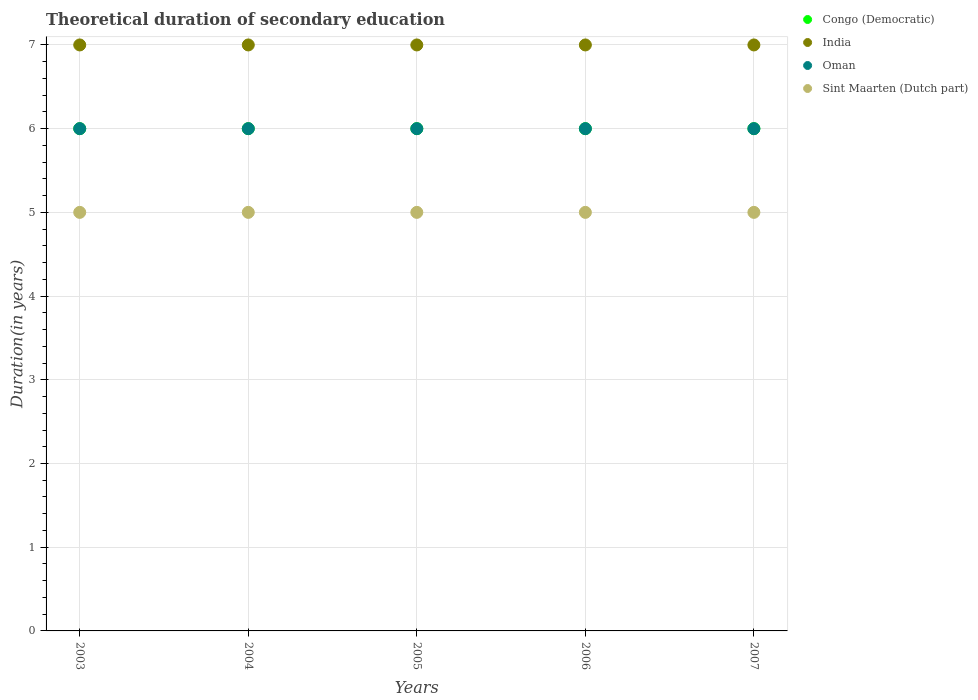How many different coloured dotlines are there?
Offer a terse response. 4. Across all years, what is the maximum total theoretical duration of secondary education in India?
Your response must be concise. 7. In which year was the total theoretical duration of secondary education in Congo (Democratic) maximum?
Offer a very short reply. 2003. What is the total total theoretical duration of secondary education in Oman in the graph?
Ensure brevity in your answer.  30. What is the average total theoretical duration of secondary education in Sint Maarten (Dutch part) per year?
Ensure brevity in your answer.  5. What is the ratio of the total theoretical duration of secondary education in Oman in 2003 to that in 2005?
Ensure brevity in your answer.  1. Is the total theoretical duration of secondary education in India in 2003 less than that in 2006?
Offer a terse response. No. Is the difference between the total theoretical duration of secondary education in Oman in 2005 and 2007 greater than the difference between the total theoretical duration of secondary education in Congo (Democratic) in 2005 and 2007?
Provide a succinct answer. No. What is the difference between the highest and the second highest total theoretical duration of secondary education in India?
Your answer should be very brief. 0. What is the difference between the highest and the lowest total theoretical duration of secondary education in Oman?
Make the answer very short. 0. Is it the case that in every year, the sum of the total theoretical duration of secondary education in Sint Maarten (Dutch part) and total theoretical duration of secondary education in Oman  is greater than the sum of total theoretical duration of secondary education in Congo (Democratic) and total theoretical duration of secondary education in India?
Your answer should be compact. No. Is the total theoretical duration of secondary education in Congo (Democratic) strictly greater than the total theoretical duration of secondary education in India over the years?
Ensure brevity in your answer.  No. Is the total theoretical duration of secondary education in Sint Maarten (Dutch part) strictly less than the total theoretical duration of secondary education in Oman over the years?
Your response must be concise. Yes. How many dotlines are there?
Keep it short and to the point. 4. How many years are there in the graph?
Your answer should be compact. 5. Where does the legend appear in the graph?
Give a very brief answer. Top right. How are the legend labels stacked?
Your answer should be very brief. Vertical. What is the title of the graph?
Offer a very short reply. Theoretical duration of secondary education. What is the label or title of the X-axis?
Your answer should be compact. Years. What is the label or title of the Y-axis?
Provide a succinct answer. Duration(in years). What is the Duration(in years) of Oman in 2003?
Ensure brevity in your answer.  6. What is the Duration(in years) of Sint Maarten (Dutch part) in 2003?
Your response must be concise. 5. What is the Duration(in years) in Oman in 2004?
Offer a terse response. 6. What is the Duration(in years) of Sint Maarten (Dutch part) in 2004?
Give a very brief answer. 5. What is the Duration(in years) of Congo (Democratic) in 2005?
Offer a terse response. 6. What is the Duration(in years) in India in 2005?
Make the answer very short. 7. What is the Duration(in years) in Oman in 2005?
Your response must be concise. 6. What is the Duration(in years) in Sint Maarten (Dutch part) in 2005?
Give a very brief answer. 5. What is the Duration(in years) in Congo (Democratic) in 2006?
Make the answer very short. 6. What is the Duration(in years) of Sint Maarten (Dutch part) in 2006?
Your answer should be compact. 5. What is the Duration(in years) of Congo (Democratic) in 2007?
Keep it short and to the point. 6. What is the Duration(in years) of India in 2007?
Offer a very short reply. 7. Across all years, what is the maximum Duration(in years) of Oman?
Keep it short and to the point. 6. Across all years, what is the maximum Duration(in years) of Sint Maarten (Dutch part)?
Ensure brevity in your answer.  5. Across all years, what is the minimum Duration(in years) in Congo (Democratic)?
Provide a succinct answer. 6. Across all years, what is the minimum Duration(in years) of India?
Provide a short and direct response. 7. What is the total Duration(in years) in Congo (Democratic) in the graph?
Provide a succinct answer. 30. What is the total Duration(in years) of India in the graph?
Make the answer very short. 35. What is the total Duration(in years) of Oman in the graph?
Provide a succinct answer. 30. What is the total Duration(in years) of Sint Maarten (Dutch part) in the graph?
Offer a very short reply. 25. What is the difference between the Duration(in years) of Oman in 2003 and that in 2004?
Provide a short and direct response. 0. What is the difference between the Duration(in years) in Sint Maarten (Dutch part) in 2003 and that in 2004?
Your answer should be very brief. 0. What is the difference between the Duration(in years) of Congo (Democratic) in 2003 and that in 2005?
Your response must be concise. 0. What is the difference between the Duration(in years) in Congo (Democratic) in 2003 and that in 2006?
Keep it short and to the point. 0. What is the difference between the Duration(in years) of India in 2003 and that in 2006?
Provide a succinct answer. 0. What is the difference between the Duration(in years) of Sint Maarten (Dutch part) in 2003 and that in 2006?
Offer a terse response. 0. What is the difference between the Duration(in years) in India in 2003 and that in 2007?
Ensure brevity in your answer.  0. What is the difference between the Duration(in years) of Congo (Democratic) in 2004 and that in 2005?
Ensure brevity in your answer.  0. What is the difference between the Duration(in years) of Sint Maarten (Dutch part) in 2004 and that in 2005?
Your answer should be compact. 0. What is the difference between the Duration(in years) in India in 2004 and that in 2006?
Your answer should be very brief. 0. What is the difference between the Duration(in years) of Oman in 2004 and that in 2006?
Ensure brevity in your answer.  0. What is the difference between the Duration(in years) of Congo (Democratic) in 2004 and that in 2007?
Offer a terse response. 0. What is the difference between the Duration(in years) in India in 2004 and that in 2007?
Give a very brief answer. 0. What is the difference between the Duration(in years) of Sint Maarten (Dutch part) in 2004 and that in 2007?
Offer a very short reply. 0. What is the difference between the Duration(in years) of India in 2005 and that in 2006?
Provide a succinct answer. 0. What is the difference between the Duration(in years) of Oman in 2005 and that in 2006?
Give a very brief answer. 0. What is the difference between the Duration(in years) in Sint Maarten (Dutch part) in 2005 and that in 2006?
Make the answer very short. 0. What is the difference between the Duration(in years) of Sint Maarten (Dutch part) in 2005 and that in 2007?
Make the answer very short. 0. What is the difference between the Duration(in years) in Sint Maarten (Dutch part) in 2006 and that in 2007?
Provide a succinct answer. 0. What is the difference between the Duration(in years) of Congo (Democratic) in 2003 and the Duration(in years) of Sint Maarten (Dutch part) in 2004?
Your response must be concise. 1. What is the difference between the Duration(in years) in Congo (Democratic) in 2003 and the Duration(in years) in India in 2005?
Give a very brief answer. -1. What is the difference between the Duration(in years) of Congo (Democratic) in 2003 and the Duration(in years) of Oman in 2005?
Offer a terse response. 0. What is the difference between the Duration(in years) of India in 2003 and the Duration(in years) of Sint Maarten (Dutch part) in 2005?
Offer a very short reply. 2. What is the difference between the Duration(in years) of Oman in 2003 and the Duration(in years) of Sint Maarten (Dutch part) in 2005?
Offer a very short reply. 1. What is the difference between the Duration(in years) in Congo (Democratic) in 2003 and the Duration(in years) in Oman in 2006?
Ensure brevity in your answer.  0. What is the difference between the Duration(in years) of Congo (Democratic) in 2003 and the Duration(in years) of Sint Maarten (Dutch part) in 2006?
Offer a very short reply. 1. What is the difference between the Duration(in years) of India in 2003 and the Duration(in years) of Sint Maarten (Dutch part) in 2007?
Keep it short and to the point. 2. What is the difference between the Duration(in years) in Oman in 2003 and the Duration(in years) in Sint Maarten (Dutch part) in 2007?
Give a very brief answer. 1. What is the difference between the Duration(in years) in Congo (Democratic) in 2004 and the Duration(in years) in Sint Maarten (Dutch part) in 2005?
Keep it short and to the point. 1. What is the difference between the Duration(in years) of India in 2004 and the Duration(in years) of Oman in 2005?
Ensure brevity in your answer.  1. What is the difference between the Duration(in years) of Congo (Democratic) in 2004 and the Duration(in years) of India in 2006?
Provide a short and direct response. -1. What is the difference between the Duration(in years) of Congo (Democratic) in 2004 and the Duration(in years) of Sint Maarten (Dutch part) in 2006?
Provide a succinct answer. 1. What is the difference between the Duration(in years) of India in 2004 and the Duration(in years) of Oman in 2006?
Offer a terse response. 1. What is the difference between the Duration(in years) of Oman in 2004 and the Duration(in years) of Sint Maarten (Dutch part) in 2006?
Give a very brief answer. 1. What is the difference between the Duration(in years) of Congo (Democratic) in 2004 and the Duration(in years) of Sint Maarten (Dutch part) in 2007?
Your answer should be very brief. 1. What is the difference between the Duration(in years) of Congo (Democratic) in 2005 and the Duration(in years) of India in 2006?
Offer a very short reply. -1. What is the difference between the Duration(in years) in Congo (Democratic) in 2005 and the Duration(in years) in Sint Maarten (Dutch part) in 2006?
Give a very brief answer. 1. What is the difference between the Duration(in years) in Oman in 2005 and the Duration(in years) in Sint Maarten (Dutch part) in 2006?
Offer a very short reply. 1. What is the difference between the Duration(in years) of Oman in 2005 and the Duration(in years) of Sint Maarten (Dutch part) in 2007?
Offer a terse response. 1. What is the difference between the Duration(in years) in India in 2006 and the Duration(in years) in Oman in 2007?
Your answer should be compact. 1. What is the average Duration(in years) of Congo (Democratic) per year?
Your answer should be compact. 6. What is the average Duration(in years) of India per year?
Make the answer very short. 7. What is the average Duration(in years) in Oman per year?
Provide a short and direct response. 6. What is the average Duration(in years) in Sint Maarten (Dutch part) per year?
Offer a terse response. 5. In the year 2003, what is the difference between the Duration(in years) in Congo (Democratic) and Duration(in years) in Oman?
Give a very brief answer. 0. In the year 2004, what is the difference between the Duration(in years) in Congo (Democratic) and Duration(in years) in India?
Your answer should be very brief. -1. In the year 2004, what is the difference between the Duration(in years) of Congo (Democratic) and Duration(in years) of Oman?
Your answer should be very brief. 0. In the year 2005, what is the difference between the Duration(in years) in Congo (Democratic) and Duration(in years) in Oman?
Your answer should be very brief. 0. In the year 2005, what is the difference between the Duration(in years) in India and Duration(in years) in Oman?
Your answer should be compact. 1. In the year 2005, what is the difference between the Duration(in years) in India and Duration(in years) in Sint Maarten (Dutch part)?
Your response must be concise. 2. In the year 2006, what is the difference between the Duration(in years) of Congo (Democratic) and Duration(in years) of Oman?
Your response must be concise. 0. In the year 2006, what is the difference between the Duration(in years) in India and Duration(in years) in Oman?
Ensure brevity in your answer.  1. In the year 2006, what is the difference between the Duration(in years) in India and Duration(in years) in Sint Maarten (Dutch part)?
Offer a very short reply. 2. In the year 2007, what is the difference between the Duration(in years) of Congo (Democratic) and Duration(in years) of Sint Maarten (Dutch part)?
Offer a very short reply. 1. In the year 2007, what is the difference between the Duration(in years) in India and Duration(in years) in Sint Maarten (Dutch part)?
Give a very brief answer. 2. In the year 2007, what is the difference between the Duration(in years) of Oman and Duration(in years) of Sint Maarten (Dutch part)?
Your answer should be very brief. 1. What is the ratio of the Duration(in years) of India in 2003 to that in 2004?
Make the answer very short. 1. What is the ratio of the Duration(in years) in Oman in 2003 to that in 2004?
Ensure brevity in your answer.  1. What is the ratio of the Duration(in years) in Sint Maarten (Dutch part) in 2003 to that in 2004?
Your response must be concise. 1. What is the ratio of the Duration(in years) of Congo (Democratic) in 2003 to that in 2005?
Your answer should be very brief. 1. What is the ratio of the Duration(in years) of Oman in 2003 to that in 2005?
Provide a short and direct response. 1. What is the ratio of the Duration(in years) of Sint Maarten (Dutch part) in 2003 to that in 2005?
Offer a terse response. 1. What is the ratio of the Duration(in years) in Congo (Democratic) in 2003 to that in 2006?
Ensure brevity in your answer.  1. What is the ratio of the Duration(in years) of India in 2003 to that in 2006?
Provide a short and direct response. 1. What is the ratio of the Duration(in years) of Sint Maarten (Dutch part) in 2003 to that in 2006?
Offer a terse response. 1. What is the ratio of the Duration(in years) of Oman in 2003 to that in 2007?
Ensure brevity in your answer.  1. What is the ratio of the Duration(in years) in Congo (Democratic) in 2004 to that in 2005?
Provide a short and direct response. 1. What is the ratio of the Duration(in years) of India in 2004 to that in 2005?
Offer a terse response. 1. What is the ratio of the Duration(in years) in Sint Maarten (Dutch part) in 2004 to that in 2006?
Your response must be concise. 1. What is the ratio of the Duration(in years) of India in 2004 to that in 2007?
Keep it short and to the point. 1. What is the ratio of the Duration(in years) of Oman in 2004 to that in 2007?
Your answer should be very brief. 1. What is the ratio of the Duration(in years) in Sint Maarten (Dutch part) in 2004 to that in 2007?
Provide a succinct answer. 1. What is the ratio of the Duration(in years) of India in 2005 to that in 2006?
Your answer should be compact. 1. What is the ratio of the Duration(in years) in Congo (Democratic) in 2005 to that in 2007?
Your answer should be very brief. 1. What is the ratio of the Duration(in years) of India in 2005 to that in 2007?
Offer a terse response. 1. What is the ratio of the Duration(in years) in Sint Maarten (Dutch part) in 2005 to that in 2007?
Provide a succinct answer. 1. What is the ratio of the Duration(in years) in India in 2006 to that in 2007?
Provide a succinct answer. 1. What is the ratio of the Duration(in years) in Oman in 2006 to that in 2007?
Your response must be concise. 1. What is the ratio of the Duration(in years) in Sint Maarten (Dutch part) in 2006 to that in 2007?
Make the answer very short. 1. What is the difference between the highest and the second highest Duration(in years) in Congo (Democratic)?
Ensure brevity in your answer.  0. What is the difference between the highest and the lowest Duration(in years) of India?
Your answer should be compact. 0. What is the difference between the highest and the lowest Duration(in years) of Oman?
Ensure brevity in your answer.  0. 